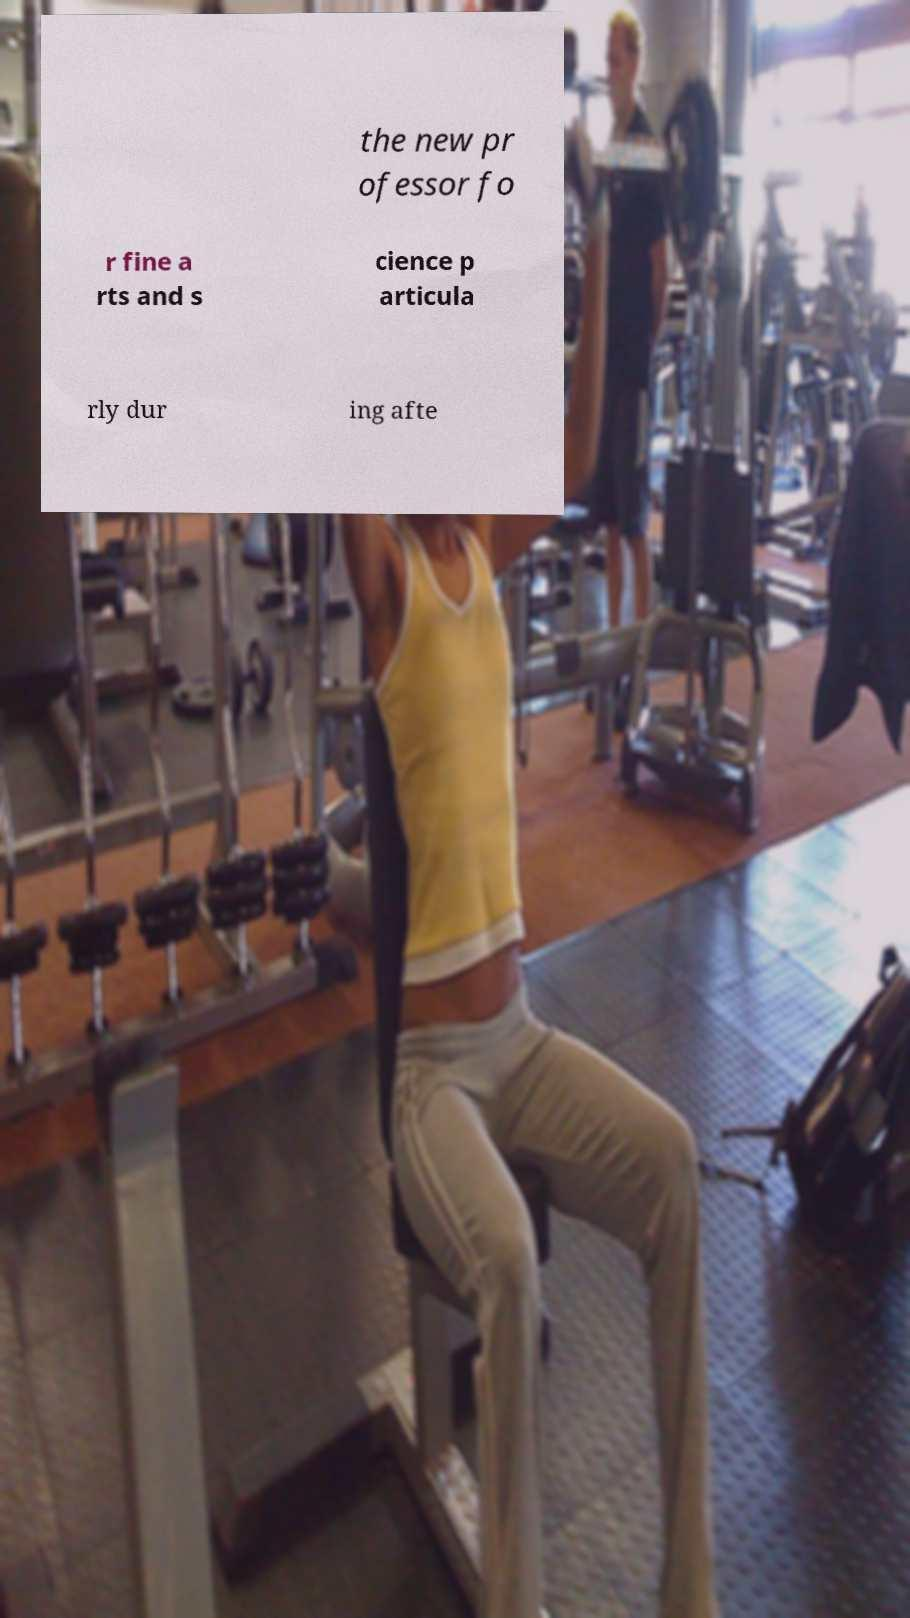Can you accurately transcribe the text from the provided image for me? the new pr ofessor fo r fine a rts and s cience p articula rly dur ing afte 